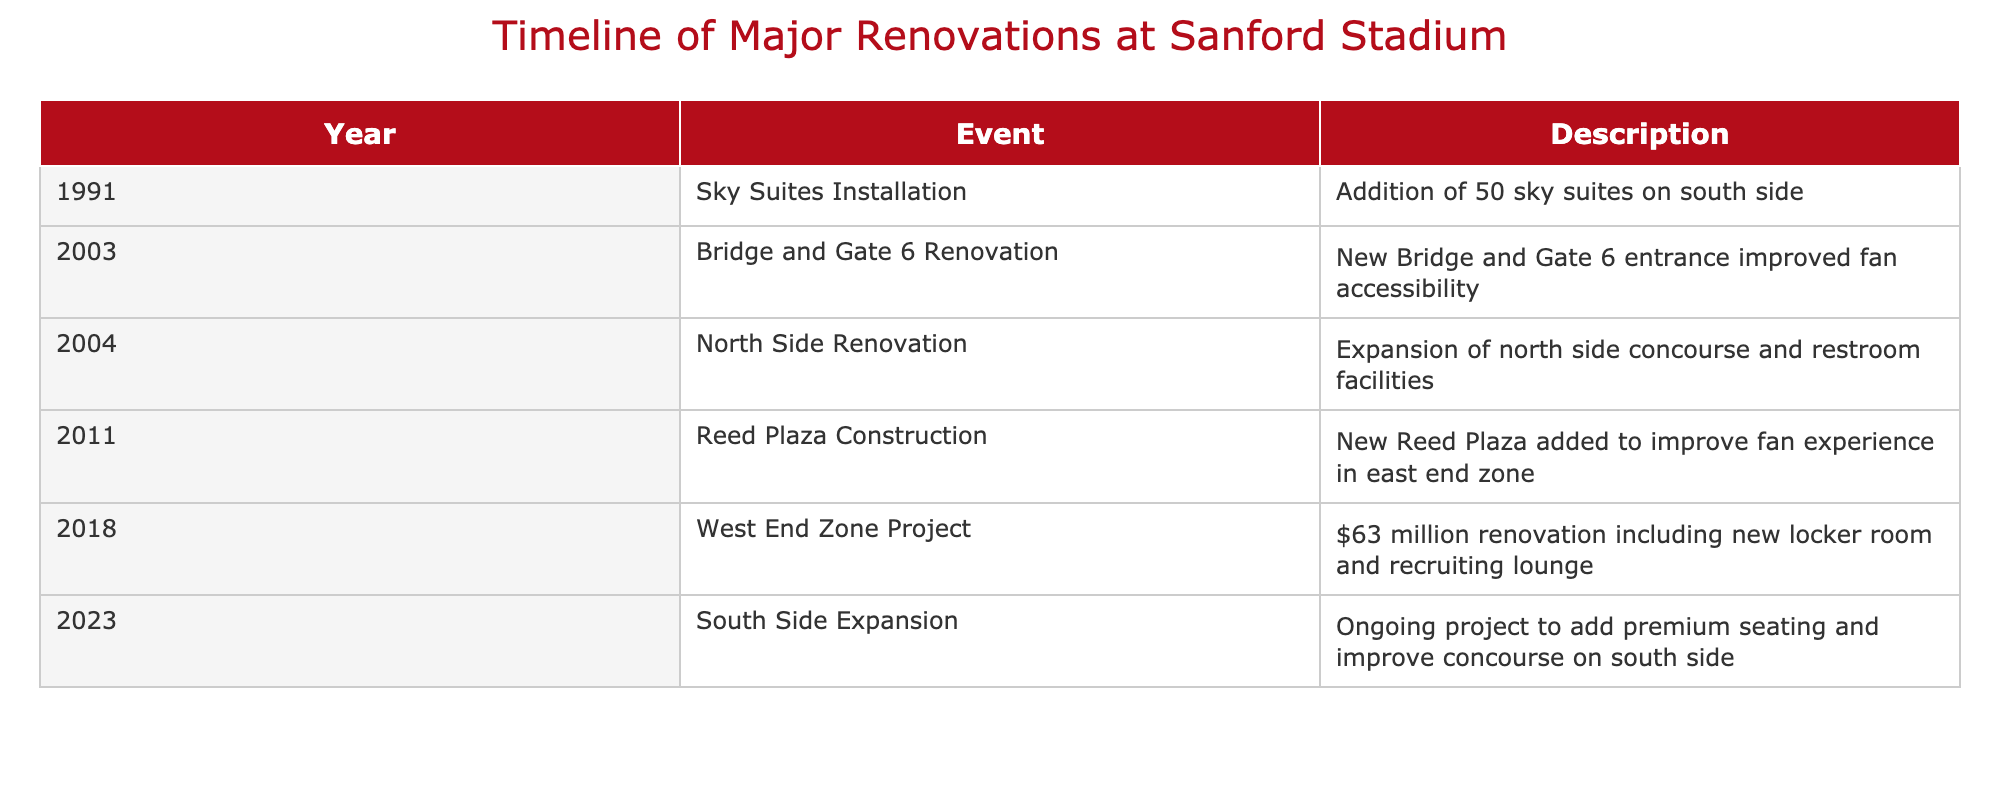What year did the South Side Expansion project begin? The table lists an event for the year 2023 that corresponds to the South Side Expansion. Therefore, the year in which this project began is 2023.
Answer: 2023 What major renovations occurred in 2011? According to the table, the only event listed for 2011 is the construction of Reed Plaza. Therefore, the major renovation for that year is Reed Plaza Construction.
Answer: Reed Plaza Construction How many events took place in the 2000s? The table shows two events in the 2000s: the Bridge and Gate 6 Renovation in 2003 and the North Side Renovation in 2004. Therefore, there were two events that took place during that decade.
Answer: 2 Which renovation had a budget of $63 million? The table describes an event in 2018: the West End Zone Project, which mentions a budget of $63 million for renovations. Thus, the renovation with this budget is the West End Zone Project.
Answer: West End Zone Project Was there any renovation completed before 2000? Looking at the timeline provided, all the events listed occurred in the 1990s or later. Since the earliest event is from 1991, there were no renovations completed before 2000.
Answer: No What improvement was made in the North Side Renovation? The table states that the North Side Renovation involved the expansion of the north side concourse and restroom facilities. This indicates that the improvements included enhancements to both concourse space and restroom access.
Answer: Expansion of concourse and restroom facilities Which event focused on enhancing fan accessibility? The table cites the Bridge and Gate 6 Renovation from 2003 as the event that improved fan accessibility with the new entrance. Thus, this event focused on enhancing accessibility for fans.
Answer: Bridge and Gate 6 Renovation What is the total number of renovation projects listed in the table? By counting all the events listed from 1991 to 2023, there are a total of six renovation projects documented in the table. Therefore, the total number of renovation projects is six.
Answer: 6 In terms of new constructions, which year had the most recent project? The South Side Expansion, listed in 2023, is the most recent project mentioned in the table. Hence, this year had the most recent construction activity in the timeline provided.
Answer: 2023 